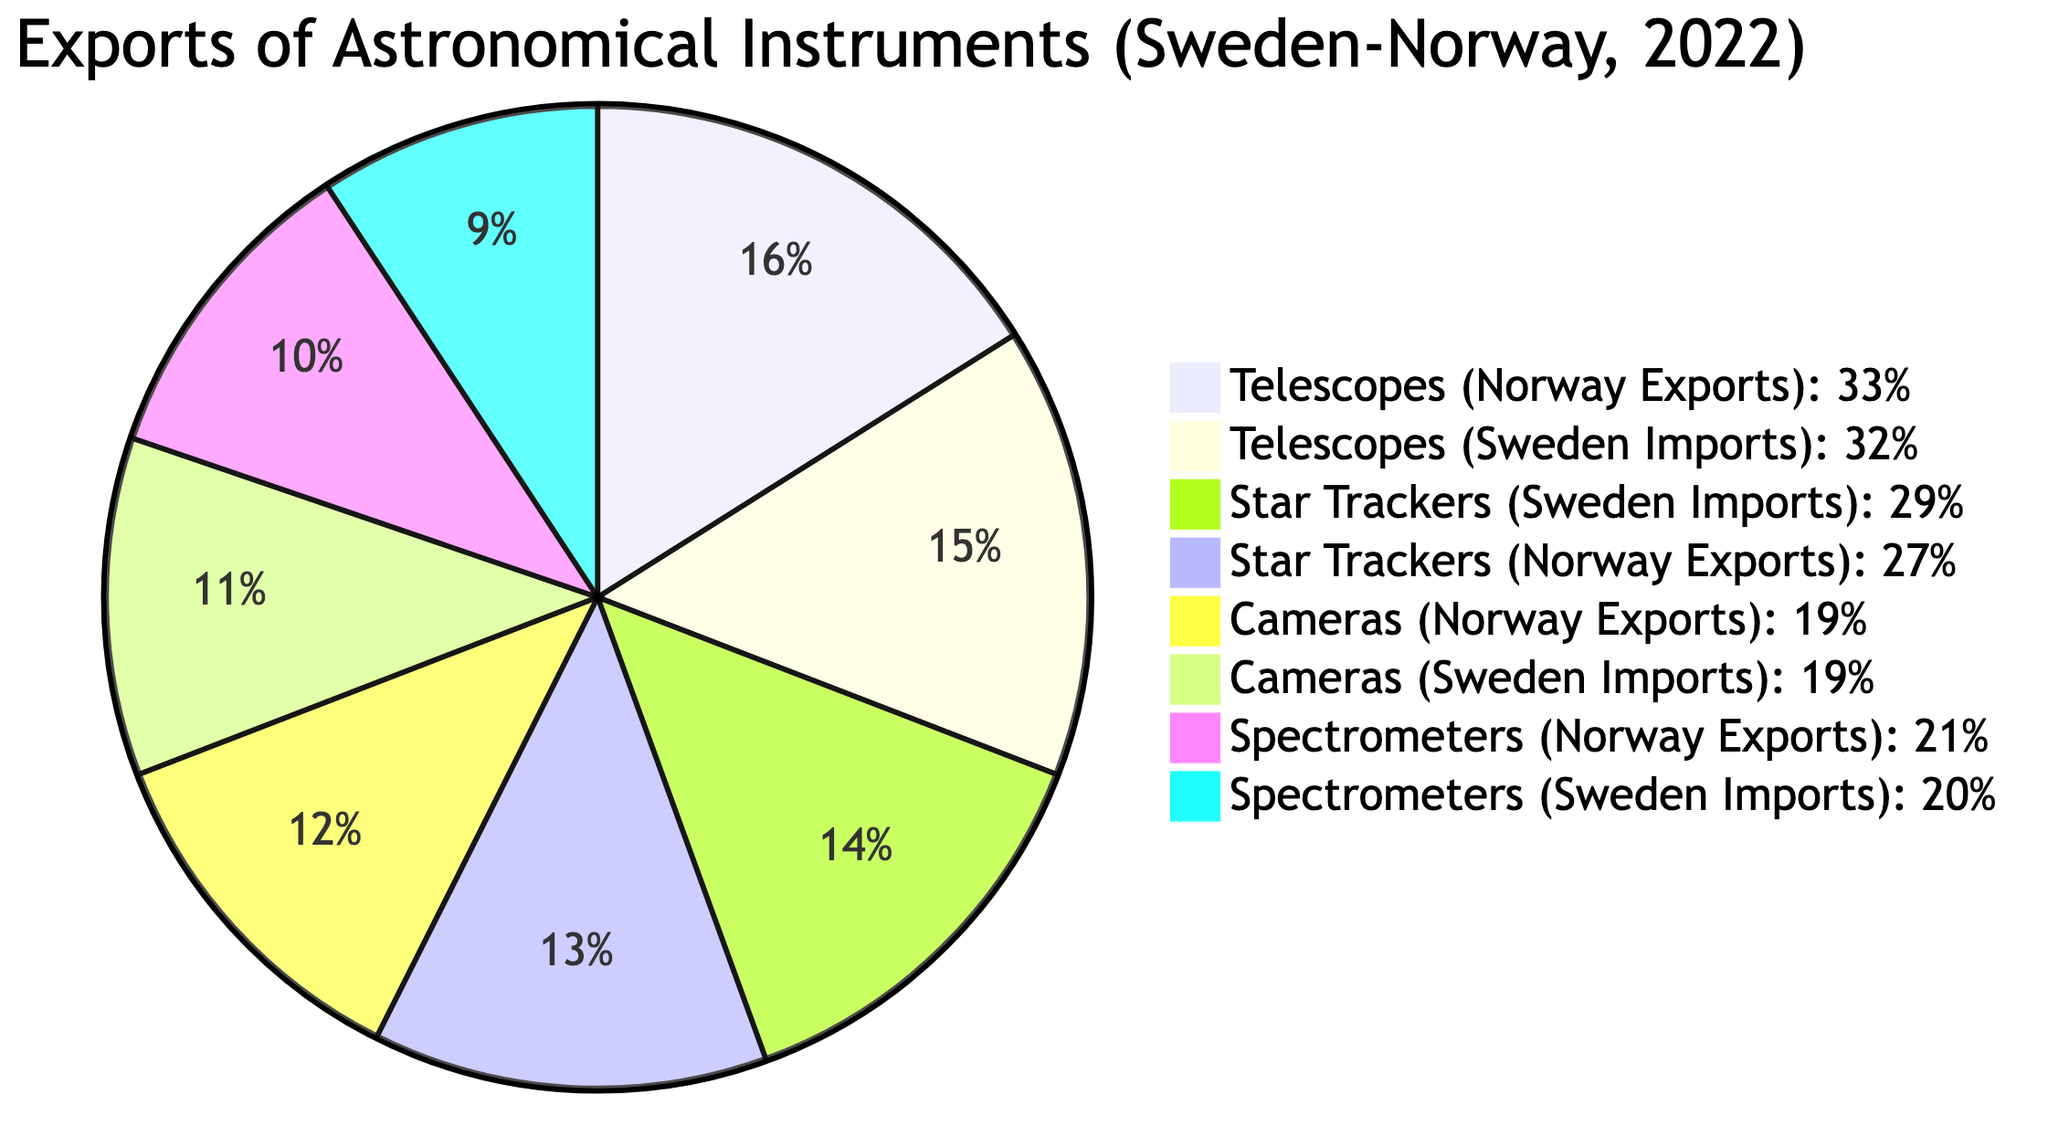What is the percentage of telescopes imported by Sweden? The diagram clearly states that telescopes (Sweden Imports) account for 32% of the total imports from Norway.
Answer: 32% What is the percentage of spectrometers exported by Norway? According to the diagram, the value for spectrometers (Norway Exports) is 21%.
Answer: 21% Which astronomical instrument has the highest percentage of imports by Sweden? By comparing the percentages of each instrument imported by Sweden, the highest value is for telescopes at 32%.
Answer: Telescopes What is the total percentage of cameras imported by Sweden and exported by Norway combined? The percentage of cameras for Sweden imports is 19% and for Norway exports is also 19%. Adding these together gives 19% + 19% = 38%.
Answer: 38% If the total imports of astronomical instruments to Sweden are 750 units, how many units of star trackers were imported? The percentage of star trackers by Sweden is 29%. Calculating this from the total gives 29% of 750 = 217.5, which rounds to 218 units.
Answer: 218 Which exported astronomical instrument from Norway is least represented in percentage? Reviewing the percentages for Norway exports, cameras, at 19%, is the least represented.
Answer: Cameras What percentage of star trackers were exported by Norway? The percentage for star trackers (Norway Exports) is given as 27%.
Answer: 27% Which instrument has the smallest percentage difference between imports and exports? By examining the differences, the smallest percentage is found between cameras: Sweden imports at 19% and Norway exports at 19%, resulting in a 0% difference.
Answer: Cameras 